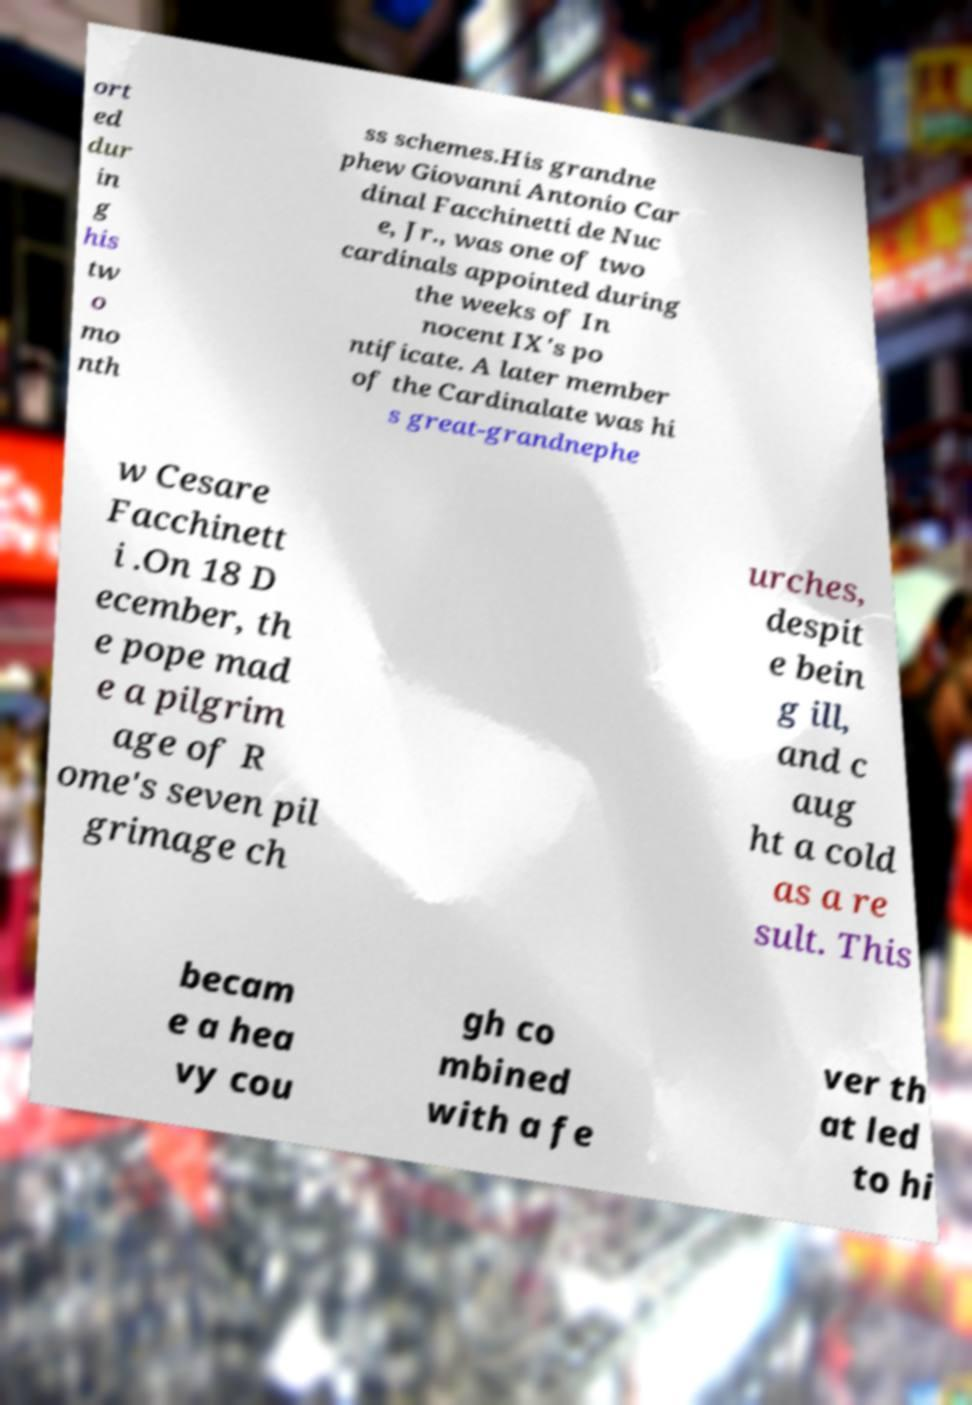What messages or text are displayed in this image? I need them in a readable, typed format. ort ed dur in g his tw o mo nth ss schemes.His grandne phew Giovanni Antonio Car dinal Facchinetti de Nuc e, Jr., was one of two cardinals appointed during the weeks of In nocent IX's po ntificate. A later member of the Cardinalate was hi s great-grandnephe w Cesare Facchinett i .On 18 D ecember, th e pope mad e a pilgrim age of R ome's seven pil grimage ch urches, despit e bein g ill, and c aug ht a cold as a re sult. This becam e a hea vy cou gh co mbined with a fe ver th at led to hi 